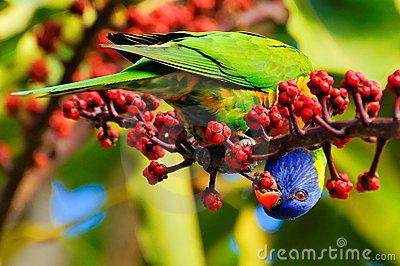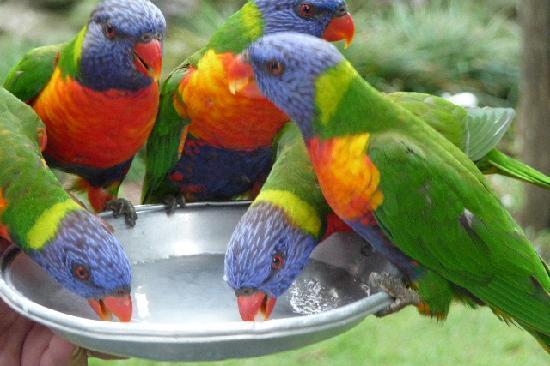The first image is the image on the left, the second image is the image on the right. Assess this claim about the two images: "An image shows a parrot perched among branches of red flowers with tendril petals.". Correct or not? Answer yes or no. No. 